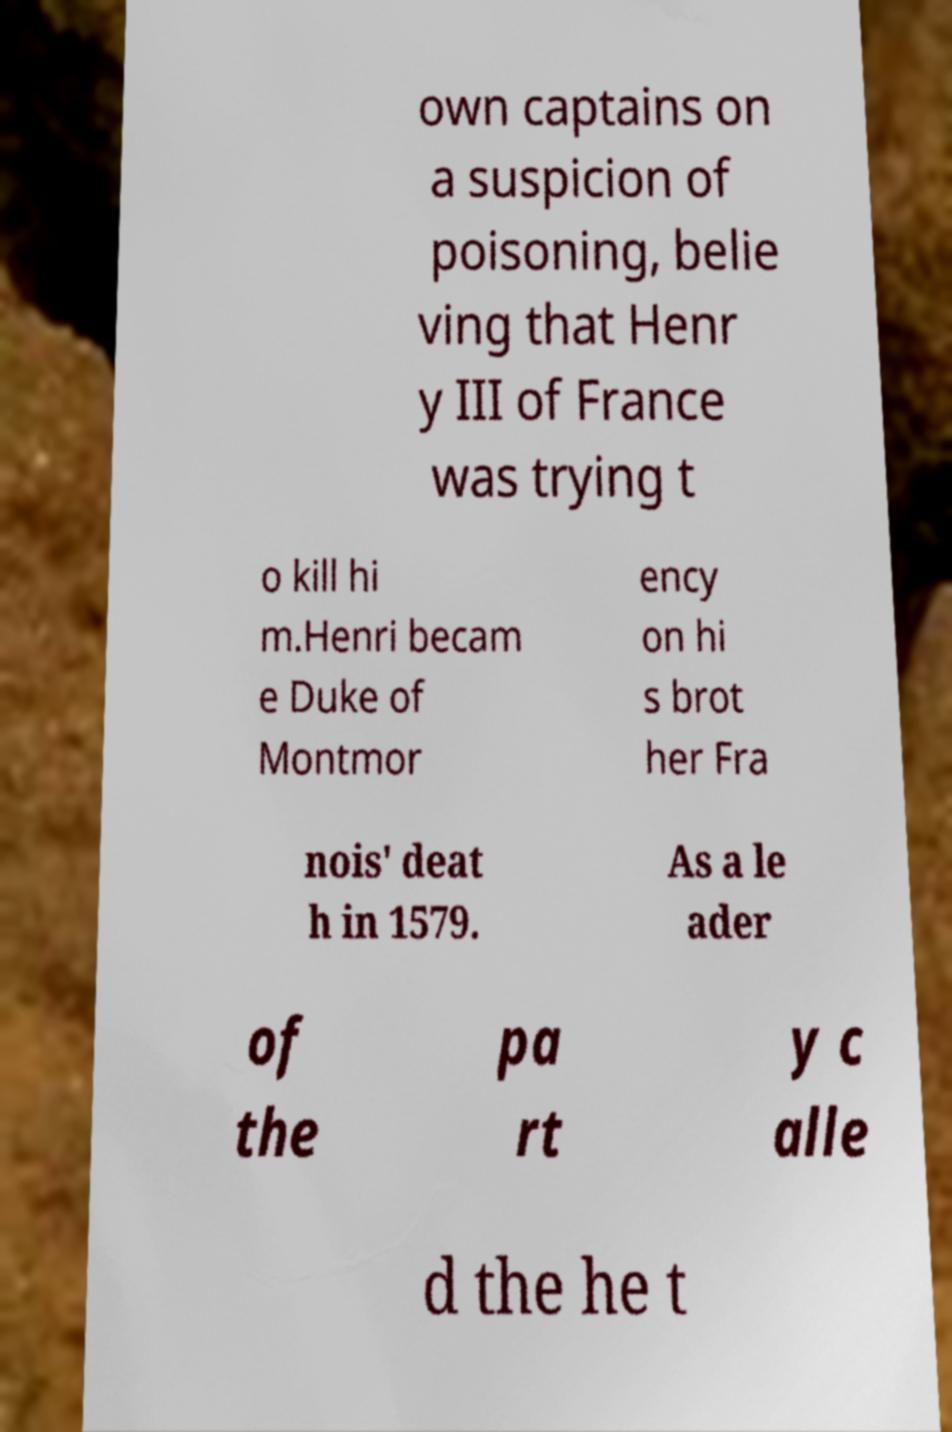Could you extract and type out the text from this image? own captains on a suspicion of poisoning, belie ving that Henr y III of France was trying t o kill hi m.Henri becam e Duke of Montmor ency on hi s brot her Fra nois' deat h in 1579. As a le ader of the pa rt y c alle d the he t 